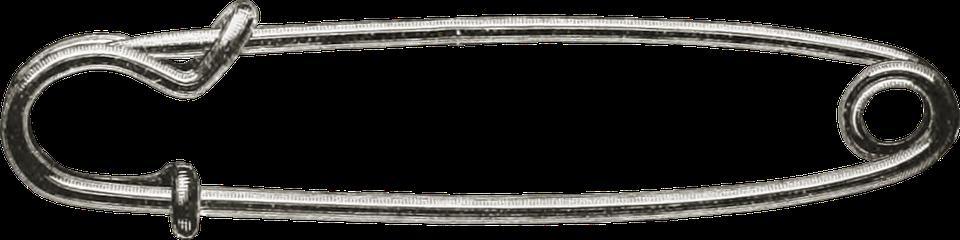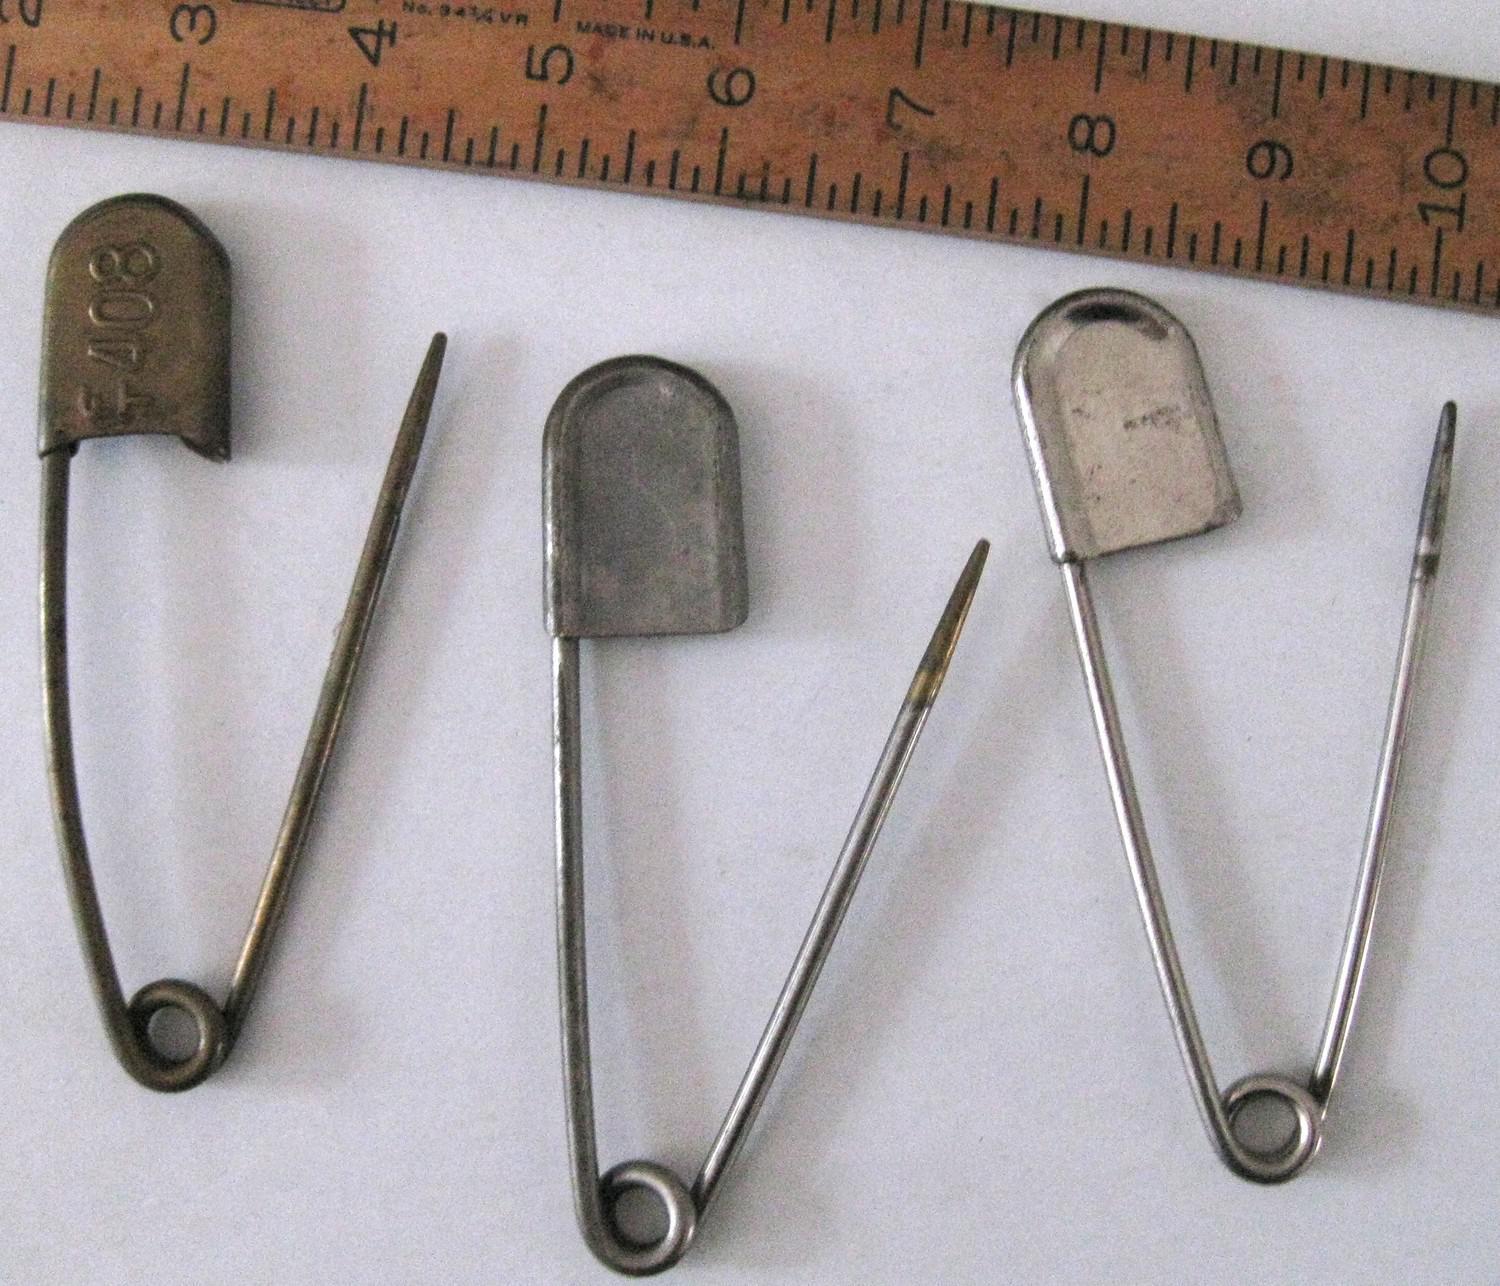The first image is the image on the left, the second image is the image on the right. For the images shown, is this caption "There are cloths pins grouped together with at least one of the pin tops colored white." true? Answer yes or no. No. 